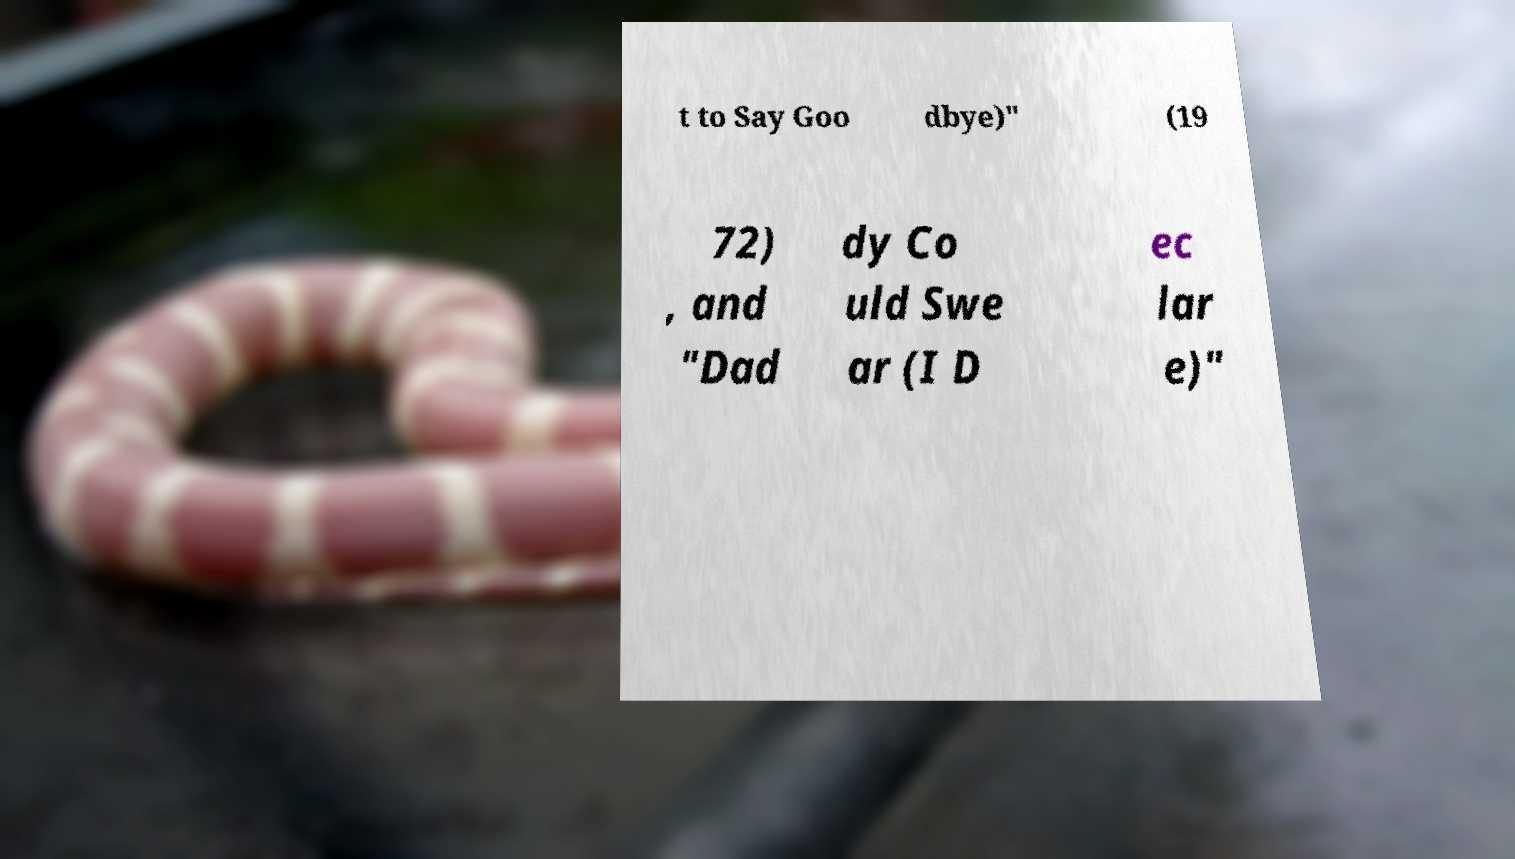For documentation purposes, I need the text within this image transcribed. Could you provide that? t to Say Goo dbye)" (19 72) , and "Dad dy Co uld Swe ar (I D ec lar e)" 